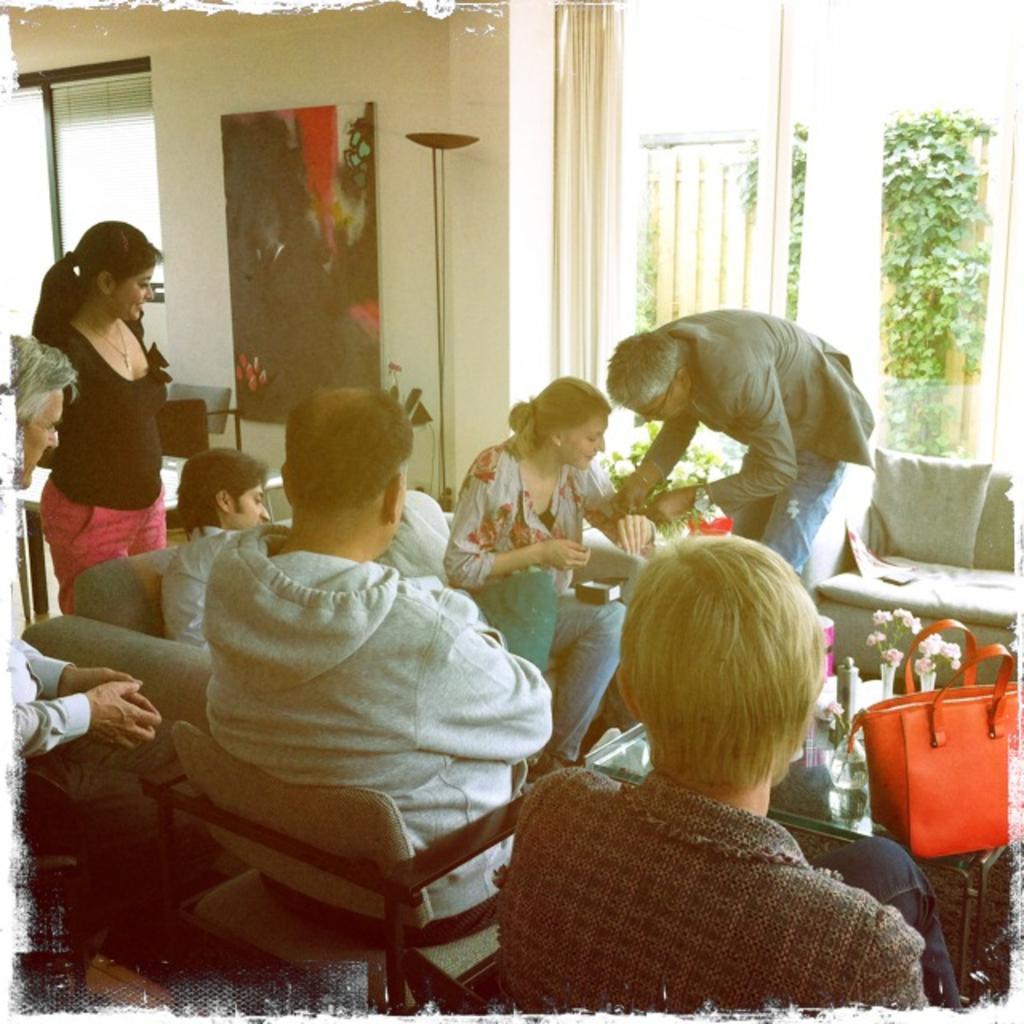How would you summarize this image in a sentence or two? In this picture we can see a group of people some are sitting and some are standing and in front of them there is table and on table we can see bag, flower and in background we can see wall, frames, curtain. 